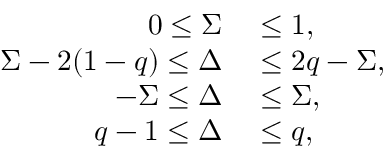Convert formula to latex. <formula><loc_0><loc_0><loc_500><loc_500>\begin{array} { r l } { 0 \leq \Sigma } & \leq 1 , } \\ { \Sigma - 2 ( 1 - q ) \leq \Delta } & \leq 2 q - \Sigma , } \\ { - \Sigma \leq \Delta } & \leq \Sigma , } \\ { q - 1 \leq \Delta } & \leq q , } \end{array}</formula> 